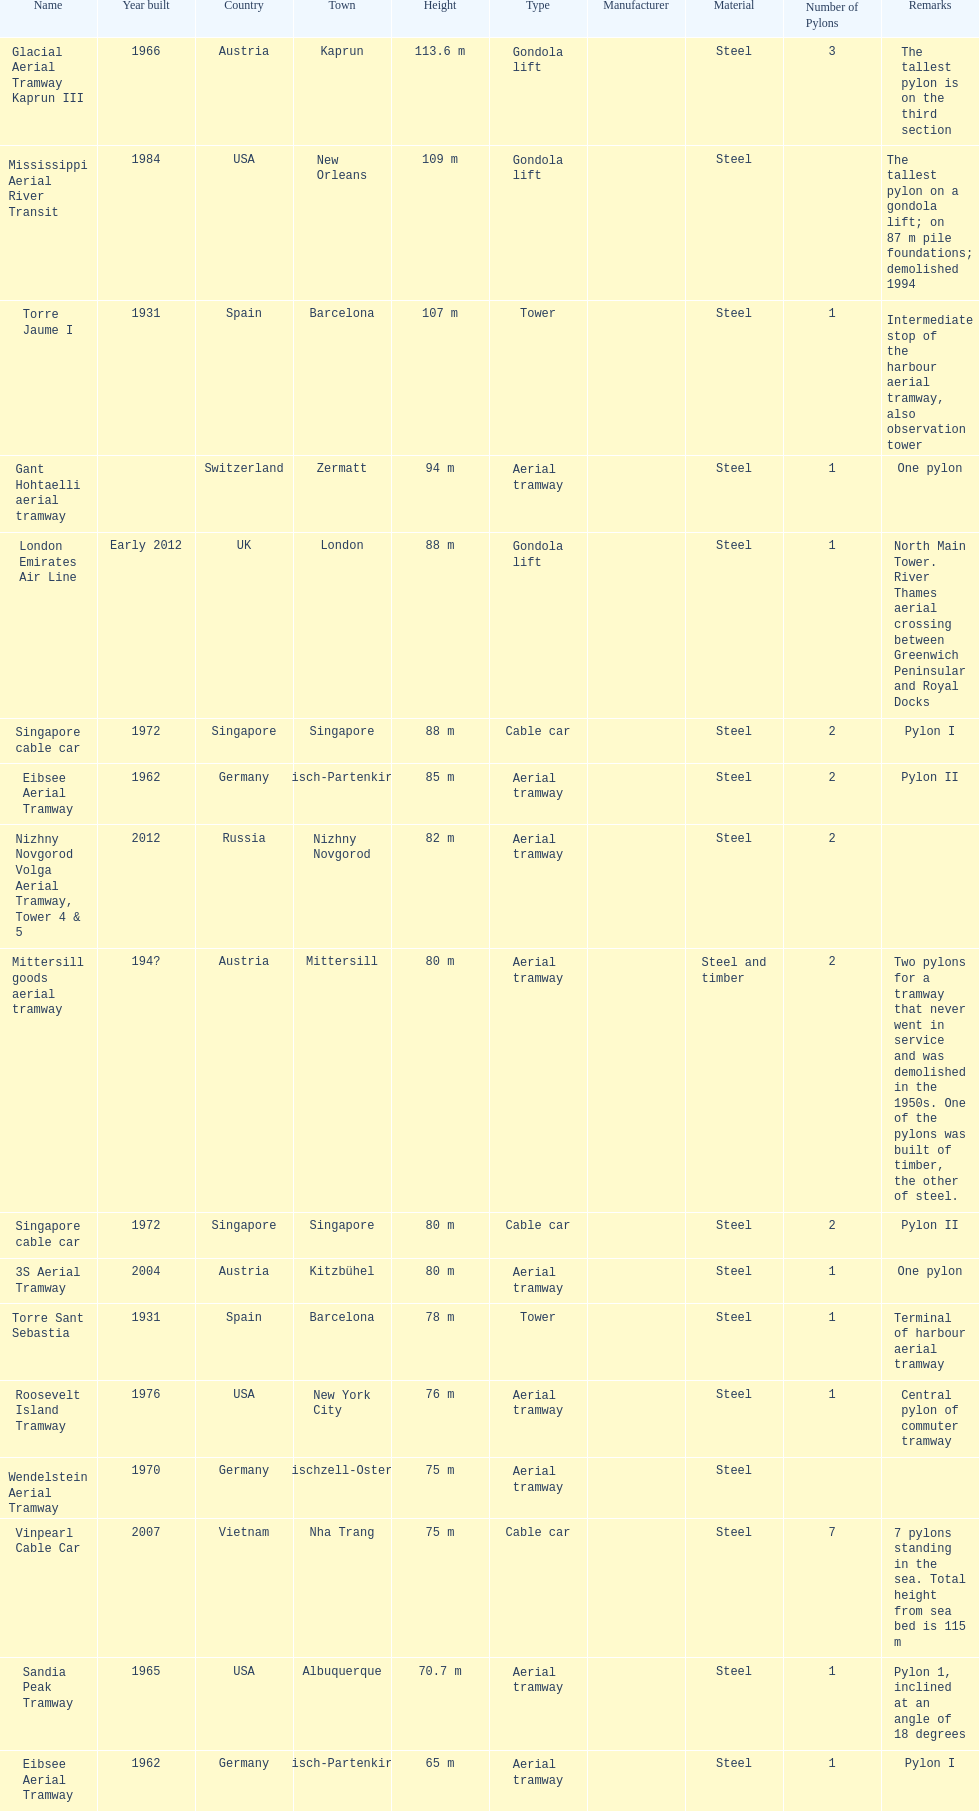List two pylons that are at most, 80 m in height. Mittersill goods aerial tramway, Singapore cable car. 